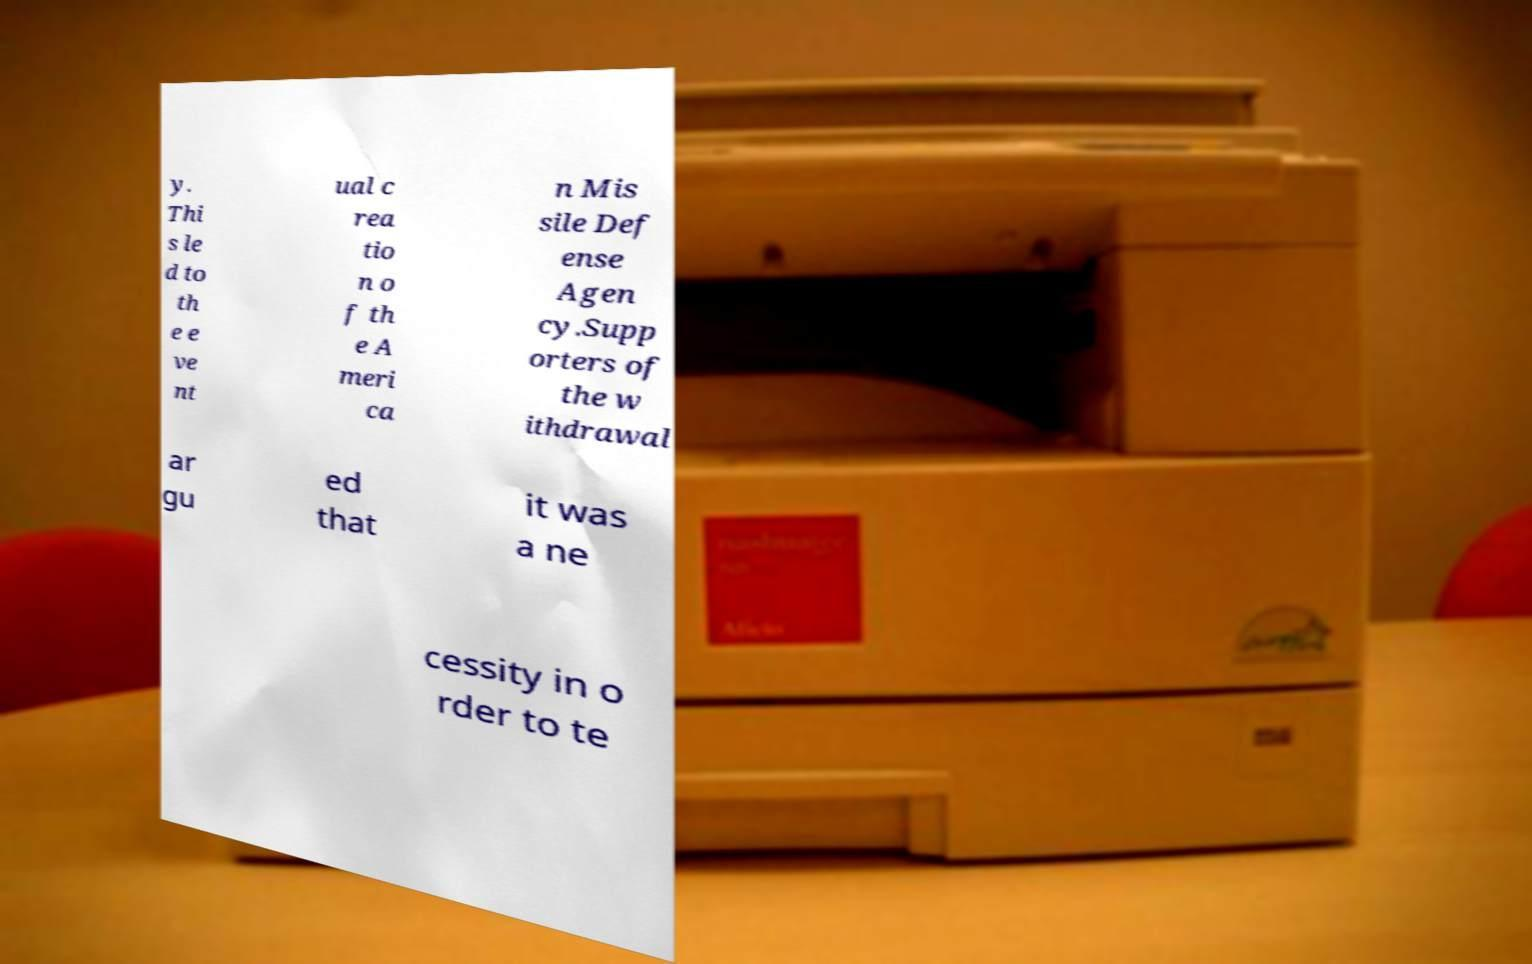Could you assist in decoding the text presented in this image and type it out clearly? y. Thi s le d to th e e ve nt ual c rea tio n o f th e A meri ca n Mis sile Def ense Agen cy.Supp orters of the w ithdrawal ar gu ed that it was a ne cessity in o rder to te 